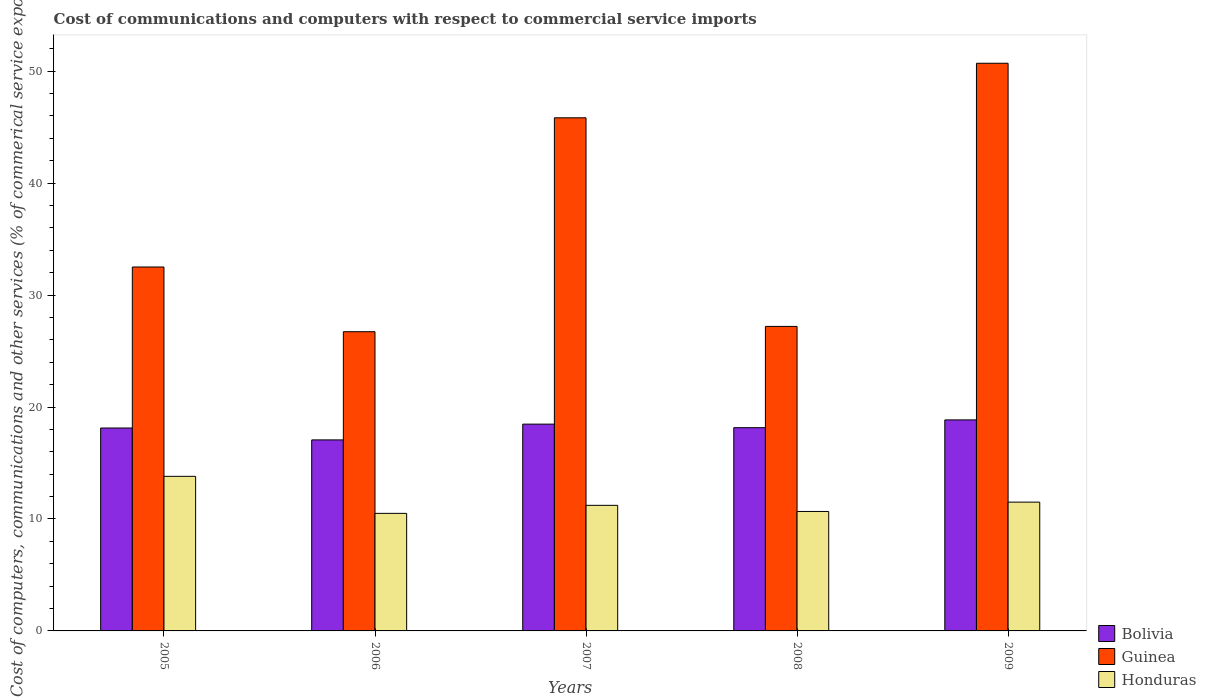How many different coloured bars are there?
Ensure brevity in your answer.  3. Are the number of bars per tick equal to the number of legend labels?
Ensure brevity in your answer.  Yes. Are the number of bars on each tick of the X-axis equal?
Keep it short and to the point. Yes. How many bars are there on the 1st tick from the left?
Provide a succinct answer. 3. How many bars are there on the 5th tick from the right?
Offer a terse response. 3. What is the cost of communications and computers in Honduras in 2007?
Your response must be concise. 11.22. Across all years, what is the maximum cost of communications and computers in Guinea?
Provide a succinct answer. 50.71. Across all years, what is the minimum cost of communications and computers in Guinea?
Offer a very short reply. 26.73. In which year was the cost of communications and computers in Guinea minimum?
Provide a short and direct response. 2006. What is the total cost of communications and computers in Honduras in the graph?
Provide a short and direct response. 57.7. What is the difference between the cost of communications and computers in Bolivia in 2007 and that in 2008?
Your answer should be very brief. 0.32. What is the difference between the cost of communications and computers in Guinea in 2007 and the cost of communications and computers in Bolivia in 2005?
Your answer should be compact. 27.71. What is the average cost of communications and computers in Guinea per year?
Make the answer very short. 36.6. In the year 2005, what is the difference between the cost of communications and computers in Guinea and cost of communications and computers in Honduras?
Ensure brevity in your answer.  18.7. In how many years, is the cost of communications and computers in Guinea greater than 48 %?
Provide a short and direct response. 1. What is the ratio of the cost of communications and computers in Honduras in 2006 to that in 2007?
Give a very brief answer. 0.94. Is the cost of communications and computers in Bolivia in 2006 less than that in 2008?
Keep it short and to the point. Yes. What is the difference between the highest and the second highest cost of communications and computers in Guinea?
Give a very brief answer. 4.87. What is the difference between the highest and the lowest cost of communications and computers in Bolivia?
Offer a terse response. 1.79. In how many years, is the cost of communications and computers in Honduras greater than the average cost of communications and computers in Honduras taken over all years?
Your answer should be very brief. 1. What does the 2nd bar from the left in 2006 represents?
Keep it short and to the point. Guinea. What does the 2nd bar from the right in 2006 represents?
Your answer should be very brief. Guinea. How many bars are there?
Provide a short and direct response. 15. How many years are there in the graph?
Provide a short and direct response. 5. What is the difference between two consecutive major ticks on the Y-axis?
Give a very brief answer. 10. Does the graph contain any zero values?
Offer a very short reply. No. Does the graph contain grids?
Keep it short and to the point. No. What is the title of the graph?
Provide a short and direct response. Cost of communications and computers with respect to commercial service imports. What is the label or title of the X-axis?
Your answer should be compact. Years. What is the label or title of the Y-axis?
Provide a short and direct response. Cost of computers, communications and other services (% of commerical service exports). What is the Cost of computers, communications and other services (% of commerical service exports) of Bolivia in 2005?
Your answer should be compact. 18.12. What is the Cost of computers, communications and other services (% of commerical service exports) of Guinea in 2005?
Your answer should be compact. 32.51. What is the Cost of computers, communications and other services (% of commerical service exports) of Honduras in 2005?
Offer a very short reply. 13.81. What is the Cost of computers, communications and other services (% of commerical service exports) in Bolivia in 2006?
Offer a terse response. 17.06. What is the Cost of computers, communications and other services (% of commerical service exports) in Guinea in 2006?
Give a very brief answer. 26.73. What is the Cost of computers, communications and other services (% of commerical service exports) in Honduras in 2006?
Ensure brevity in your answer.  10.5. What is the Cost of computers, communications and other services (% of commerical service exports) of Bolivia in 2007?
Your answer should be compact. 18.47. What is the Cost of computers, communications and other services (% of commerical service exports) of Guinea in 2007?
Your answer should be compact. 45.83. What is the Cost of computers, communications and other services (% of commerical service exports) of Honduras in 2007?
Give a very brief answer. 11.22. What is the Cost of computers, communications and other services (% of commerical service exports) in Bolivia in 2008?
Ensure brevity in your answer.  18.15. What is the Cost of computers, communications and other services (% of commerical service exports) in Guinea in 2008?
Your answer should be compact. 27.2. What is the Cost of computers, communications and other services (% of commerical service exports) of Honduras in 2008?
Make the answer very short. 10.67. What is the Cost of computers, communications and other services (% of commerical service exports) of Bolivia in 2009?
Offer a terse response. 18.85. What is the Cost of computers, communications and other services (% of commerical service exports) of Guinea in 2009?
Provide a short and direct response. 50.71. What is the Cost of computers, communications and other services (% of commerical service exports) in Honduras in 2009?
Your answer should be compact. 11.5. Across all years, what is the maximum Cost of computers, communications and other services (% of commerical service exports) of Bolivia?
Ensure brevity in your answer.  18.85. Across all years, what is the maximum Cost of computers, communications and other services (% of commerical service exports) in Guinea?
Give a very brief answer. 50.71. Across all years, what is the maximum Cost of computers, communications and other services (% of commerical service exports) of Honduras?
Give a very brief answer. 13.81. Across all years, what is the minimum Cost of computers, communications and other services (% of commerical service exports) of Bolivia?
Make the answer very short. 17.06. Across all years, what is the minimum Cost of computers, communications and other services (% of commerical service exports) of Guinea?
Provide a short and direct response. 26.73. Across all years, what is the minimum Cost of computers, communications and other services (% of commerical service exports) of Honduras?
Your response must be concise. 10.5. What is the total Cost of computers, communications and other services (% of commerical service exports) of Bolivia in the graph?
Your answer should be very brief. 90.66. What is the total Cost of computers, communications and other services (% of commerical service exports) in Guinea in the graph?
Your answer should be very brief. 182.98. What is the total Cost of computers, communications and other services (% of commerical service exports) in Honduras in the graph?
Your answer should be very brief. 57.7. What is the difference between the Cost of computers, communications and other services (% of commerical service exports) in Bolivia in 2005 and that in 2006?
Offer a very short reply. 1.06. What is the difference between the Cost of computers, communications and other services (% of commerical service exports) of Guinea in 2005 and that in 2006?
Give a very brief answer. 5.78. What is the difference between the Cost of computers, communications and other services (% of commerical service exports) in Honduras in 2005 and that in 2006?
Your response must be concise. 3.31. What is the difference between the Cost of computers, communications and other services (% of commerical service exports) of Bolivia in 2005 and that in 2007?
Keep it short and to the point. -0.35. What is the difference between the Cost of computers, communications and other services (% of commerical service exports) in Guinea in 2005 and that in 2007?
Make the answer very short. -13.33. What is the difference between the Cost of computers, communications and other services (% of commerical service exports) of Honduras in 2005 and that in 2007?
Offer a very short reply. 2.59. What is the difference between the Cost of computers, communications and other services (% of commerical service exports) in Bolivia in 2005 and that in 2008?
Your answer should be very brief. -0.03. What is the difference between the Cost of computers, communications and other services (% of commerical service exports) in Guinea in 2005 and that in 2008?
Provide a short and direct response. 5.31. What is the difference between the Cost of computers, communications and other services (% of commerical service exports) in Honduras in 2005 and that in 2008?
Provide a short and direct response. 3.14. What is the difference between the Cost of computers, communications and other services (% of commerical service exports) in Bolivia in 2005 and that in 2009?
Provide a short and direct response. -0.72. What is the difference between the Cost of computers, communications and other services (% of commerical service exports) in Guinea in 2005 and that in 2009?
Ensure brevity in your answer.  -18.2. What is the difference between the Cost of computers, communications and other services (% of commerical service exports) in Honduras in 2005 and that in 2009?
Provide a short and direct response. 2.3. What is the difference between the Cost of computers, communications and other services (% of commerical service exports) of Bolivia in 2006 and that in 2007?
Provide a succinct answer. -1.41. What is the difference between the Cost of computers, communications and other services (% of commerical service exports) of Guinea in 2006 and that in 2007?
Offer a very short reply. -19.11. What is the difference between the Cost of computers, communications and other services (% of commerical service exports) in Honduras in 2006 and that in 2007?
Your answer should be very brief. -0.72. What is the difference between the Cost of computers, communications and other services (% of commerical service exports) in Bolivia in 2006 and that in 2008?
Provide a succinct answer. -1.09. What is the difference between the Cost of computers, communications and other services (% of commerical service exports) of Guinea in 2006 and that in 2008?
Offer a very short reply. -0.47. What is the difference between the Cost of computers, communications and other services (% of commerical service exports) in Honduras in 2006 and that in 2008?
Give a very brief answer. -0.17. What is the difference between the Cost of computers, communications and other services (% of commerical service exports) in Bolivia in 2006 and that in 2009?
Offer a very short reply. -1.79. What is the difference between the Cost of computers, communications and other services (% of commerical service exports) of Guinea in 2006 and that in 2009?
Give a very brief answer. -23.98. What is the difference between the Cost of computers, communications and other services (% of commerical service exports) of Honduras in 2006 and that in 2009?
Make the answer very short. -1. What is the difference between the Cost of computers, communications and other services (% of commerical service exports) in Bolivia in 2007 and that in 2008?
Your answer should be very brief. 0.32. What is the difference between the Cost of computers, communications and other services (% of commerical service exports) of Guinea in 2007 and that in 2008?
Keep it short and to the point. 18.63. What is the difference between the Cost of computers, communications and other services (% of commerical service exports) in Honduras in 2007 and that in 2008?
Keep it short and to the point. 0.55. What is the difference between the Cost of computers, communications and other services (% of commerical service exports) of Bolivia in 2007 and that in 2009?
Ensure brevity in your answer.  -0.38. What is the difference between the Cost of computers, communications and other services (% of commerical service exports) of Guinea in 2007 and that in 2009?
Your answer should be compact. -4.87. What is the difference between the Cost of computers, communications and other services (% of commerical service exports) of Honduras in 2007 and that in 2009?
Keep it short and to the point. -0.29. What is the difference between the Cost of computers, communications and other services (% of commerical service exports) in Bolivia in 2008 and that in 2009?
Give a very brief answer. -0.69. What is the difference between the Cost of computers, communications and other services (% of commerical service exports) of Guinea in 2008 and that in 2009?
Provide a short and direct response. -23.51. What is the difference between the Cost of computers, communications and other services (% of commerical service exports) of Honduras in 2008 and that in 2009?
Provide a short and direct response. -0.83. What is the difference between the Cost of computers, communications and other services (% of commerical service exports) of Bolivia in 2005 and the Cost of computers, communications and other services (% of commerical service exports) of Guinea in 2006?
Your response must be concise. -8.6. What is the difference between the Cost of computers, communications and other services (% of commerical service exports) of Bolivia in 2005 and the Cost of computers, communications and other services (% of commerical service exports) of Honduras in 2006?
Ensure brevity in your answer.  7.62. What is the difference between the Cost of computers, communications and other services (% of commerical service exports) in Guinea in 2005 and the Cost of computers, communications and other services (% of commerical service exports) in Honduras in 2006?
Your answer should be very brief. 22.01. What is the difference between the Cost of computers, communications and other services (% of commerical service exports) in Bolivia in 2005 and the Cost of computers, communications and other services (% of commerical service exports) in Guinea in 2007?
Make the answer very short. -27.71. What is the difference between the Cost of computers, communications and other services (% of commerical service exports) of Bolivia in 2005 and the Cost of computers, communications and other services (% of commerical service exports) of Honduras in 2007?
Make the answer very short. 6.91. What is the difference between the Cost of computers, communications and other services (% of commerical service exports) of Guinea in 2005 and the Cost of computers, communications and other services (% of commerical service exports) of Honduras in 2007?
Keep it short and to the point. 21.29. What is the difference between the Cost of computers, communications and other services (% of commerical service exports) of Bolivia in 2005 and the Cost of computers, communications and other services (% of commerical service exports) of Guinea in 2008?
Your answer should be very brief. -9.07. What is the difference between the Cost of computers, communications and other services (% of commerical service exports) of Bolivia in 2005 and the Cost of computers, communications and other services (% of commerical service exports) of Honduras in 2008?
Provide a succinct answer. 7.45. What is the difference between the Cost of computers, communications and other services (% of commerical service exports) of Guinea in 2005 and the Cost of computers, communications and other services (% of commerical service exports) of Honduras in 2008?
Provide a succinct answer. 21.84. What is the difference between the Cost of computers, communications and other services (% of commerical service exports) of Bolivia in 2005 and the Cost of computers, communications and other services (% of commerical service exports) of Guinea in 2009?
Your answer should be very brief. -32.58. What is the difference between the Cost of computers, communications and other services (% of commerical service exports) in Bolivia in 2005 and the Cost of computers, communications and other services (% of commerical service exports) in Honduras in 2009?
Keep it short and to the point. 6.62. What is the difference between the Cost of computers, communications and other services (% of commerical service exports) in Guinea in 2005 and the Cost of computers, communications and other services (% of commerical service exports) in Honduras in 2009?
Make the answer very short. 21. What is the difference between the Cost of computers, communications and other services (% of commerical service exports) of Bolivia in 2006 and the Cost of computers, communications and other services (% of commerical service exports) of Guinea in 2007?
Offer a very short reply. -28.77. What is the difference between the Cost of computers, communications and other services (% of commerical service exports) in Bolivia in 2006 and the Cost of computers, communications and other services (% of commerical service exports) in Honduras in 2007?
Your answer should be compact. 5.84. What is the difference between the Cost of computers, communications and other services (% of commerical service exports) in Guinea in 2006 and the Cost of computers, communications and other services (% of commerical service exports) in Honduras in 2007?
Provide a succinct answer. 15.51. What is the difference between the Cost of computers, communications and other services (% of commerical service exports) in Bolivia in 2006 and the Cost of computers, communications and other services (% of commerical service exports) in Guinea in 2008?
Your response must be concise. -10.14. What is the difference between the Cost of computers, communications and other services (% of commerical service exports) in Bolivia in 2006 and the Cost of computers, communications and other services (% of commerical service exports) in Honduras in 2008?
Provide a succinct answer. 6.39. What is the difference between the Cost of computers, communications and other services (% of commerical service exports) of Guinea in 2006 and the Cost of computers, communications and other services (% of commerical service exports) of Honduras in 2008?
Your response must be concise. 16.06. What is the difference between the Cost of computers, communications and other services (% of commerical service exports) in Bolivia in 2006 and the Cost of computers, communications and other services (% of commerical service exports) in Guinea in 2009?
Give a very brief answer. -33.64. What is the difference between the Cost of computers, communications and other services (% of commerical service exports) of Bolivia in 2006 and the Cost of computers, communications and other services (% of commerical service exports) of Honduras in 2009?
Your response must be concise. 5.56. What is the difference between the Cost of computers, communications and other services (% of commerical service exports) in Guinea in 2006 and the Cost of computers, communications and other services (% of commerical service exports) in Honduras in 2009?
Provide a succinct answer. 15.22. What is the difference between the Cost of computers, communications and other services (% of commerical service exports) in Bolivia in 2007 and the Cost of computers, communications and other services (% of commerical service exports) in Guinea in 2008?
Your answer should be very brief. -8.73. What is the difference between the Cost of computers, communications and other services (% of commerical service exports) of Bolivia in 2007 and the Cost of computers, communications and other services (% of commerical service exports) of Honduras in 2008?
Your answer should be compact. 7.8. What is the difference between the Cost of computers, communications and other services (% of commerical service exports) in Guinea in 2007 and the Cost of computers, communications and other services (% of commerical service exports) in Honduras in 2008?
Give a very brief answer. 35.16. What is the difference between the Cost of computers, communications and other services (% of commerical service exports) of Bolivia in 2007 and the Cost of computers, communications and other services (% of commerical service exports) of Guinea in 2009?
Your response must be concise. -32.24. What is the difference between the Cost of computers, communications and other services (% of commerical service exports) in Bolivia in 2007 and the Cost of computers, communications and other services (% of commerical service exports) in Honduras in 2009?
Provide a succinct answer. 6.97. What is the difference between the Cost of computers, communications and other services (% of commerical service exports) of Guinea in 2007 and the Cost of computers, communications and other services (% of commerical service exports) of Honduras in 2009?
Your response must be concise. 34.33. What is the difference between the Cost of computers, communications and other services (% of commerical service exports) of Bolivia in 2008 and the Cost of computers, communications and other services (% of commerical service exports) of Guinea in 2009?
Give a very brief answer. -32.55. What is the difference between the Cost of computers, communications and other services (% of commerical service exports) in Bolivia in 2008 and the Cost of computers, communications and other services (% of commerical service exports) in Honduras in 2009?
Your response must be concise. 6.65. What is the difference between the Cost of computers, communications and other services (% of commerical service exports) in Guinea in 2008 and the Cost of computers, communications and other services (% of commerical service exports) in Honduras in 2009?
Make the answer very short. 15.7. What is the average Cost of computers, communications and other services (% of commerical service exports) in Bolivia per year?
Provide a short and direct response. 18.13. What is the average Cost of computers, communications and other services (% of commerical service exports) of Guinea per year?
Ensure brevity in your answer.  36.6. What is the average Cost of computers, communications and other services (% of commerical service exports) in Honduras per year?
Provide a succinct answer. 11.54. In the year 2005, what is the difference between the Cost of computers, communications and other services (% of commerical service exports) of Bolivia and Cost of computers, communications and other services (% of commerical service exports) of Guinea?
Offer a terse response. -14.38. In the year 2005, what is the difference between the Cost of computers, communications and other services (% of commerical service exports) in Bolivia and Cost of computers, communications and other services (% of commerical service exports) in Honduras?
Give a very brief answer. 4.32. In the year 2005, what is the difference between the Cost of computers, communications and other services (% of commerical service exports) of Guinea and Cost of computers, communications and other services (% of commerical service exports) of Honduras?
Provide a short and direct response. 18.7. In the year 2006, what is the difference between the Cost of computers, communications and other services (% of commerical service exports) in Bolivia and Cost of computers, communications and other services (% of commerical service exports) in Guinea?
Offer a very short reply. -9.66. In the year 2006, what is the difference between the Cost of computers, communications and other services (% of commerical service exports) of Bolivia and Cost of computers, communications and other services (% of commerical service exports) of Honduras?
Ensure brevity in your answer.  6.56. In the year 2006, what is the difference between the Cost of computers, communications and other services (% of commerical service exports) of Guinea and Cost of computers, communications and other services (% of commerical service exports) of Honduras?
Make the answer very short. 16.23. In the year 2007, what is the difference between the Cost of computers, communications and other services (% of commerical service exports) of Bolivia and Cost of computers, communications and other services (% of commerical service exports) of Guinea?
Offer a very short reply. -27.36. In the year 2007, what is the difference between the Cost of computers, communications and other services (% of commerical service exports) in Bolivia and Cost of computers, communications and other services (% of commerical service exports) in Honduras?
Make the answer very short. 7.25. In the year 2007, what is the difference between the Cost of computers, communications and other services (% of commerical service exports) of Guinea and Cost of computers, communications and other services (% of commerical service exports) of Honduras?
Make the answer very short. 34.62. In the year 2008, what is the difference between the Cost of computers, communications and other services (% of commerical service exports) in Bolivia and Cost of computers, communications and other services (% of commerical service exports) in Guinea?
Your answer should be very brief. -9.04. In the year 2008, what is the difference between the Cost of computers, communications and other services (% of commerical service exports) of Bolivia and Cost of computers, communications and other services (% of commerical service exports) of Honduras?
Ensure brevity in your answer.  7.48. In the year 2008, what is the difference between the Cost of computers, communications and other services (% of commerical service exports) in Guinea and Cost of computers, communications and other services (% of commerical service exports) in Honduras?
Your answer should be compact. 16.53. In the year 2009, what is the difference between the Cost of computers, communications and other services (% of commerical service exports) in Bolivia and Cost of computers, communications and other services (% of commerical service exports) in Guinea?
Your answer should be compact. -31.86. In the year 2009, what is the difference between the Cost of computers, communications and other services (% of commerical service exports) in Bolivia and Cost of computers, communications and other services (% of commerical service exports) in Honduras?
Provide a short and direct response. 7.35. In the year 2009, what is the difference between the Cost of computers, communications and other services (% of commerical service exports) of Guinea and Cost of computers, communications and other services (% of commerical service exports) of Honduras?
Keep it short and to the point. 39.2. What is the ratio of the Cost of computers, communications and other services (% of commerical service exports) of Bolivia in 2005 to that in 2006?
Make the answer very short. 1.06. What is the ratio of the Cost of computers, communications and other services (% of commerical service exports) in Guinea in 2005 to that in 2006?
Your answer should be very brief. 1.22. What is the ratio of the Cost of computers, communications and other services (% of commerical service exports) in Honduras in 2005 to that in 2006?
Your answer should be compact. 1.31. What is the ratio of the Cost of computers, communications and other services (% of commerical service exports) of Bolivia in 2005 to that in 2007?
Give a very brief answer. 0.98. What is the ratio of the Cost of computers, communications and other services (% of commerical service exports) of Guinea in 2005 to that in 2007?
Provide a succinct answer. 0.71. What is the ratio of the Cost of computers, communications and other services (% of commerical service exports) of Honduras in 2005 to that in 2007?
Provide a succinct answer. 1.23. What is the ratio of the Cost of computers, communications and other services (% of commerical service exports) of Guinea in 2005 to that in 2008?
Make the answer very short. 1.2. What is the ratio of the Cost of computers, communications and other services (% of commerical service exports) of Honduras in 2005 to that in 2008?
Your response must be concise. 1.29. What is the ratio of the Cost of computers, communications and other services (% of commerical service exports) of Bolivia in 2005 to that in 2009?
Your answer should be very brief. 0.96. What is the ratio of the Cost of computers, communications and other services (% of commerical service exports) in Guinea in 2005 to that in 2009?
Keep it short and to the point. 0.64. What is the ratio of the Cost of computers, communications and other services (% of commerical service exports) of Honduras in 2005 to that in 2009?
Your answer should be very brief. 1.2. What is the ratio of the Cost of computers, communications and other services (% of commerical service exports) in Bolivia in 2006 to that in 2007?
Offer a terse response. 0.92. What is the ratio of the Cost of computers, communications and other services (% of commerical service exports) in Guinea in 2006 to that in 2007?
Your response must be concise. 0.58. What is the ratio of the Cost of computers, communications and other services (% of commerical service exports) in Honduras in 2006 to that in 2007?
Offer a terse response. 0.94. What is the ratio of the Cost of computers, communications and other services (% of commerical service exports) of Bolivia in 2006 to that in 2008?
Provide a short and direct response. 0.94. What is the ratio of the Cost of computers, communications and other services (% of commerical service exports) in Guinea in 2006 to that in 2008?
Provide a succinct answer. 0.98. What is the ratio of the Cost of computers, communications and other services (% of commerical service exports) in Bolivia in 2006 to that in 2009?
Offer a very short reply. 0.91. What is the ratio of the Cost of computers, communications and other services (% of commerical service exports) of Guinea in 2006 to that in 2009?
Your answer should be compact. 0.53. What is the ratio of the Cost of computers, communications and other services (% of commerical service exports) in Honduras in 2006 to that in 2009?
Offer a terse response. 0.91. What is the ratio of the Cost of computers, communications and other services (% of commerical service exports) of Bolivia in 2007 to that in 2008?
Make the answer very short. 1.02. What is the ratio of the Cost of computers, communications and other services (% of commerical service exports) of Guinea in 2007 to that in 2008?
Provide a short and direct response. 1.69. What is the ratio of the Cost of computers, communications and other services (% of commerical service exports) in Honduras in 2007 to that in 2008?
Provide a succinct answer. 1.05. What is the ratio of the Cost of computers, communications and other services (% of commerical service exports) of Bolivia in 2007 to that in 2009?
Offer a very short reply. 0.98. What is the ratio of the Cost of computers, communications and other services (% of commerical service exports) in Guinea in 2007 to that in 2009?
Give a very brief answer. 0.9. What is the ratio of the Cost of computers, communications and other services (% of commerical service exports) of Honduras in 2007 to that in 2009?
Your response must be concise. 0.98. What is the ratio of the Cost of computers, communications and other services (% of commerical service exports) in Bolivia in 2008 to that in 2009?
Your answer should be very brief. 0.96. What is the ratio of the Cost of computers, communications and other services (% of commerical service exports) in Guinea in 2008 to that in 2009?
Ensure brevity in your answer.  0.54. What is the ratio of the Cost of computers, communications and other services (% of commerical service exports) of Honduras in 2008 to that in 2009?
Ensure brevity in your answer.  0.93. What is the difference between the highest and the second highest Cost of computers, communications and other services (% of commerical service exports) of Bolivia?
Your answer should be compact. 0.38. What is the difference between the highest and the second highest Cost of computers, communications and other services (% of commerical service exports) of Guinea?
Your answer should be compact. 4.87. What is the difference between the highest and the second highest Cost of computers, communications and other services (% of commerical service exports) in Honduras?
Offer a terse response. 2.3. What is the difference between the highest and the lowest Cost of computers, communications and other services (% of commerical service exports) of Bolivia?
Offer a very short reply. 1.79. What is the difference between the highest and the lowest Cost of computers, communications and other services (% of commerical service exports) of Guinea?
Provide a short and direct response. 23.98. What is the difference between the highest and the lowest Cost of computers, communications and other services (% of commerical service exports) in Honduras?
Ensure brevity in your answer.  3.31. 